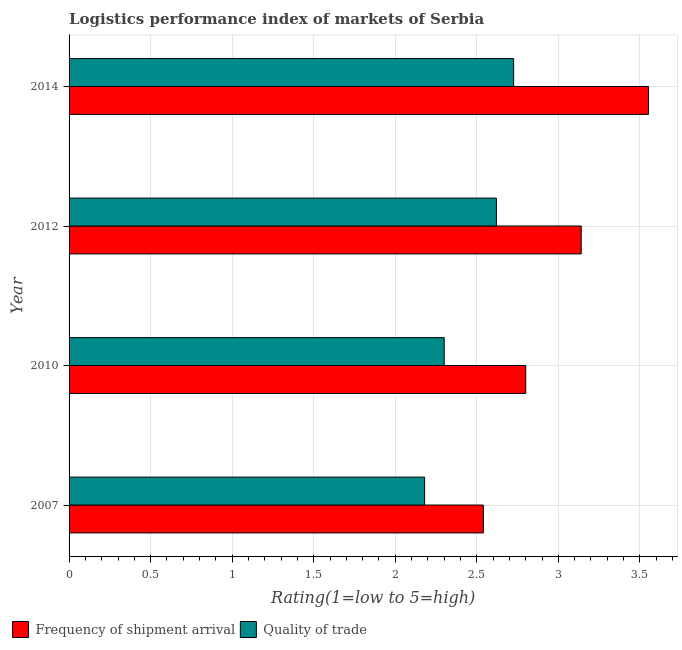Are the number of bars per tick equal to the number of legend labels?
Your response must be concise. Yes. What is the lpi of frequency of shipment arrival in 2007?
Ensure brevity in your answer.  2.54. Across all years, what is the maximum lpi quality of trade?
Ensure brevity in your answer.  2.73. Across all years, what is the minimum lpi of frequency of shipment arrival?
Give a very brief answer. 2.54. In which year was the lpi quality of trade maximum?
Your answer should be compact. 2014. What is the total lpi of frequency of shipment arrival in the graph?
Offer a very short reply. 12.03. What is the difference between the lpi quality of trade in 2010 and that in 2014?
Provide a succinct answer. -0.43. What is the difference between the lpi of frequency of shipment arrival in 2010 and the lpi quality of trade in 2007?
Keep it short and to the point. 0.62. What is the average lpi of frequency of shipment arrival per year?
Provide a succinct answer. 3.01. In the year 2014, what is the difference between the lpi of frequency of shipment arrival and lpi quality of trade?
Offer a terse response. 0.83. What is the ratio of the lpi quality of trade in 2010 to that in 2012?
Ensure brevity in your answer.  0.88. Is the difference between the lpi of frequency of shipment arrival in 2007 and 2010 greater than the difference between the lpi quality of trade in 2007 and 2010?
Provide a succinct answer. No. What is the difference between the highest and the second highest lpi of frequency of shipment arrival?
Your answer should be compact. 0.41. What is the difference between the highest and the lowest lpi quality of trade?
Make the answer very short. 0.55. Is the sum of the lpi of frequency of shipment arrival in 2007 and 2010 greater than the maximum lpi quality of trade across all years?
Your answer should be very brief. Yes. What does the 2nd bar from the top in 2012 represents?
Your answer should be very brief. Frequency of shipment arrival. What does the 2nd bar from the bottom in 2010 represents?
Your response must be concise. Quality of trade. Are all the bars in the graph horizontal?
Give a very brief answer. Yes. Are the values on the major ticks of X-axis written in scientific E-notation?
Offer a very short reply. No. Does the graph contain grids?
Provide a succinct answer. Yes. Where does the legend appear in the graph?
Your response must be concise. Bottom left. What is the title of the graph?
Your response must be concise. Logistics performance index of markets of Serbia. What is the label or title of the X-axis?
Offer a terse response. Rating(1=low to 5=high). What is the Rating(1=low to 5=high) in Frequency of shipment arrival in 2007?
Your response must be concise. 2.54. What is the Rating(1=low to 5=high) in Quality of trade in 2007?
Provide a succinct answer. 2.18. What is the Rating(1=low to 5=high) of Frequency of shipment arrival in 2010?
Your answer should be compact. 2.8. What is the Rating(1=low to 5=high) in Frequency of shipment arrival in 2012?
Your answer should be compact. 3.14. What is the Rating(1=low to 5=high) of Quality of trade in 2012?
Make the answer very short. 2.62. What is the Rating(1=low to 5=high) of Frequency of shipment arrival in 2014?
Your answer should be compact. 3.55. What is the Rating(1=low to 5=high) in Quality of trade in 2014?
Provide a short and direct response. 2.73. Across all years, what is the maximum Rating(1=low to 5=high) in Frequency of shipment arrival?
Provide a short and direct response. 3.55. Across all years, what is the maximum Rating(1=low to 5=high) of Quality of trade?
Ensure brevity in your answer.  2.73. Across all years, what is the minimum Rating(1=low to 5=high) in Frequency of shipment arrival?
Provide a short and direct response. 2.54. Across all years, what is the minimum Rating(1=low to 5=high) of Quality of trade?
Your response must be concise. 2.18. What is the total Rating(1=low to 5=high) in Frequency of shipment arrival in the graph?
Your answer should be compact. 12.03. What is the total Rating(1=low to 5=high) in Quality of trade in the graph?
Provide a short and direct response. 9.83. What is the difference between the Rating(1=low to 5=high) of Frequency of shipment arrival in 2007 and that in 2010?
Your response must be concise. -0.26. What is the difference between the Rating(1=low to 5=high) in Quality of trade in 2007 and that in 2010?
Ensure brevity in your answer.  -0.12. What is the difference between the Rating(1=low to 5=high) of Quality of trade in 2007 and that in 2012?
Your answer should be very brief. -0.44. What is the difference between the Rating(1=low to 5=high) of Frequency of shipment arrival in 2007 and that in 2014?
Ensure brevity in your answer.  -1.01. What is the difference between the Rating(1=low to 5=high) of Quality of trade in 2007 and that in 2014?
Keep it short and to the point. -0.55. What is the difference between the Rating(1=low to 5=high) in Frequency of shipment arrival in 2010 and that in 2012?
Offer a very short reply. -0.34. What is the difference between the Rating(1=low to 5=high) in Quality of trade in 2010 and that in 2012?
Offer a very short reply. -0.32. What is the difference between the Rating(1=low to 5=high) of Frequency of shipment arrival in 2010 and that in 2014?
Ensure brevity in your answer.  -0.75. What is the difference between the Rating(1=low to 5=high) in Quality of trade in 2010 and that in 2014?
Provide a succinct answer. -0.43. What is the difference between the Rating(1=low to 5=high) of Frequency of shipment arrival in 2012 and that in 2014?
Provide a short and direct response. -0.41. What is the difference between the Rating(1=low to 5=high) in Quality of trade in 2012 and that in 2014?
Offer a terse response. -0.11. What is the difference between the Rating(1=low to 5=high) of Frequency of shipment arrival in 2007 and the Rating(1=low to 5=high) of Quality of trade in 2010?
Your answer should be compact. 0.24. What is the difference between the Rating(1=low to 5=high) of Frequency of shipment arrival in 2007 and the Rating(1=low to 5=high) of Quality of trade in 2012?
Your answer should be compact. -0.08. What is the difference between the Rating(1=low to 5=high) of Frequency of shipment arrival in 2007 and the Rating(1=low to 5=high) of Quality of trade in 2014?
Offer a terse response. -0.19. What is the difference between the Rating(1=low to 5=high) in Frequency of shipment arrival in 2010 and the Rating(1=low to 5=high) in Quality of trade in 2012?
Your response must be concise. 0.18. What is the difference between the Rating(1=low to 5=high) in Frequency of shipment arrival in 2010 and the Rating(1=low to 5=high) in Quality of trade in 2014?
Your answer should be compact. 0.07. What is the difference between the Rating(1=low to 5=high) of Frequency of shipment arrival in 2012 and the Rating(1=low to 5=high) of Quality of trade in 2014?
Give a very brief answer. 0.41. What is the average Rating(1=low to 5=high) in Frequency of shipment arrival per year?
Your answer should be compact. 3.01. What is the average Rating(1=low to 5=high) of Quality of trade per year?
Ensure brevity in your answer.  2.46. In the year 2007, what is the difference between the Rating(1=low to 5=high) of Frequency of shipment arrival and Rating(1=low to 5=high) of Quality of trade?
Keep it short and to the point. 0.36. In the year 2010, what is the difference between the Rating(1=low to 5=high) in Frequency of shipment arrival and Rating(1=low to 5=high) in Quality of trade?
Keep it short and to the point. 0.5. In the year 2012, what is the difference between the Rating(1=low to 5=high) of Frequency of shipment arrival and Rating(1=low to 5=high) of Quality of trade?
Give a very brief answer. 0.52. In the year 2014, what is the difference between the Rating(1=low to 5=high) of Frequency of shipment arrival and Rating(1=low to 5=high) of Quality of trade?
Keep it short and to the point. 0.83. What is the ratio of the Rating(1=low to 5=high) of Frequency of shipment arrival in 2007 to that in 2010?
Make the answer very short. 0.91. What is the ratio of the Rating(1=low to 5=high) of Quality of trade in 2007 to that in 2010?
Your response must be concise. 0.95. What is the ratio of the Rating(1=low to 5=high) in Frequency of shipment arrival in 2007 to that in 2012?
Offer a very short reply. 0.81. What is the ratio of the Rating(1=low to 5=high) of Quality of trade in 2007 to that in 2012?
Provide a succinct answer. 0.83. What is the ratio of the Rating(1=low to 5=high) of Frequency of shipment arrival in 2007 to that in 2014?
Your answer should be very brief. 0.71. What is the ratio of the Rating(1=low to 5=high) of Quality of trade in 2007 to that in 2014?
Offer a very short reply. 0.8. What is the ratio of the Rating(1=low to 5=high) of Frequency of shipment arrival in 2010 to that in 2012?
Offer a terse response. 0.89. What is the ratio of the Rating(1=low to 5=high) of Quality of trade in 2010 to that in 2012?
Offer a terse response. 0.88. What is the ratio of the Rating(1=low to 5=high) in Frequency of shipment arrival in 2010 to that in 2014?
Your answer should be compact. 0.79. What is the ratio of the Rating(1=low to 5=high) in Quality of trade in 2010 to that in 2014?
Ensure brevity in your answer.  0.84. What is the ratio of the Rating(1=low to 5=high) of Frequency of shipment arrival in 2012 to that in 2014?
Provide a succinct answer. 0.88. What is the ratio of the Rating(1=low to 5=high) in Quality of trade in 2012 to that in 2014?
Offer a terse response. 0.96. What is the difference between the highest and the second highest Rating(1=low to 5=high) in Frequency of shipment arrival?
Provide a succinct answer. 0.41. What is the difference between the highest and the second highest Rating(1=low to 5=high) in Quality of trade?
Offer a terse response. 0.11. What is the difference between the highest and the lowest Rating(1=low to 5=high) of Frequency of shipment arrival?
Ensure brevity in your answer.  1.01. What is the difference between the highest and the lowest Rating(1=low to 5=high) in Quality of trade?
Provide a short and direct response. 0.55. 